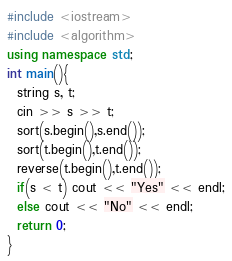Convert code to text. <code><loc_0><loc_0><loc_500><loc_500><_C++_>#include <iostream>
#include <algorithm>
using namespace std;
int main(){
  string s, t;
  cin >> s >> t;
  sort(s.begin(),s.end());
  sort(t.begin(),t.end());
  reverse(t.begin(),t.end());
  if(s < t) cout << "Yes" << endl;
  else cout << "No" << endl;
  return 0;
}
</code> 